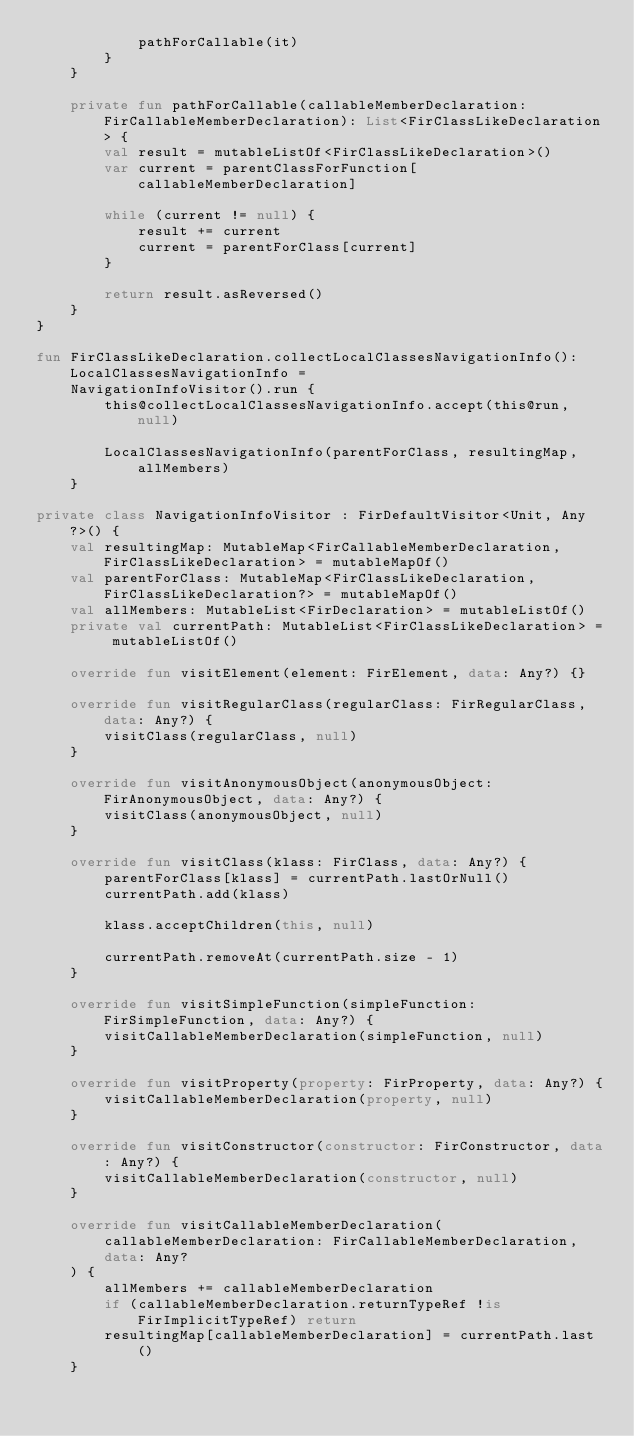<code> <loc_0><loc_0><loc_500><loc_500><_Kotlin_>            pathForCallable(it)
        }
    }

    private fun pathForCallable(callableMemberDeclaration: FirCallableMemberDeclaration): List<FirClassLikeDeclaration> {
        val result = mutableListOf<FirClassLikeDeclaration>()
        var current = parentClassForFunction[callableMemberDeclaration]

        while (current != null) {
            result += current
            current = parentForClass[current]
        }

        return result.asReversed()
    }
}

fun FirClassLikeDeclaration.collectLocalClassesNavigationInfo(): LocalClassesNavigationInfo =
    NavigationInfoVisitor().run {
        this@collectLocalClassesNavigationInfo.accept(this@run, null)

        LocalClassesNavigationInfo(parentForClass, resultingMap, allMembers)
    }

private class NavigationInfoVisitor : FirDefaultVisitor<Unit, Any?>() {
    val resultingMap: MutableMap<FirCallableMemberDeclaration, FirClassLikeDeclaration> = mutableMapOf()
    val parentForClass: MutableMap<FirClassLikeDeclaration, FirClassLikeDeclaration?> = mutableMapOf()
    val allMembers: MutableList<FirDeclaration> = mutableListOf()
    private val currentPath: MutableList<FirClassLikeDeclaration> = mutableListOf()

    override fun visitElement(element: FirElement, data: Any?) {}

    override fun visitRegularClass(regularClass: FirRegularClass, data: Any?) {
        visitClass(regularClass, null)
    }

    override fun visitAnonymousObject(anonymousObject: FirAnonymousObject, data: Any?) {
        visitClass(anonymousObject, null)
    }

    override fun visitClass(klass: FirClass, data: Any?) {
        parentForClass[klass] = currentPath.lastOrNull()
        currentPath.add(klass)

        klass.acceptChildren(this, null)

        currentPath.removeAt(currentPath.size - 1)
    }

    override fun visitSimpleFunction(simpleFunction: FirSimpleFunction, data: Any?) {
        visitCallableMemberDeclaration(simpleFunction, null)
    }

    override fun visitProperty(property: FirProperty, data: Any?) {
        visitCallableMemberDeclaration(property, null)
    }

    override fun visitConstructor(constructor: FirConstructor, data: Any?) {
        visitCallableMemberDeclaration(constructor, null)
    }

    override fun visitCallableMemberDeclaration(
        callableMemberDeclaration: FirCallableMemberDeclaration,
        data: Any?
    ) {
        allMembers += callableMemberDeclaration
        if (callableMemberDeclaration.returnTypeRef !is FirImplicitTypeRef) return
        resultingMap[callableMemberDeclaration] = currentPath.last()
    }
</code> 